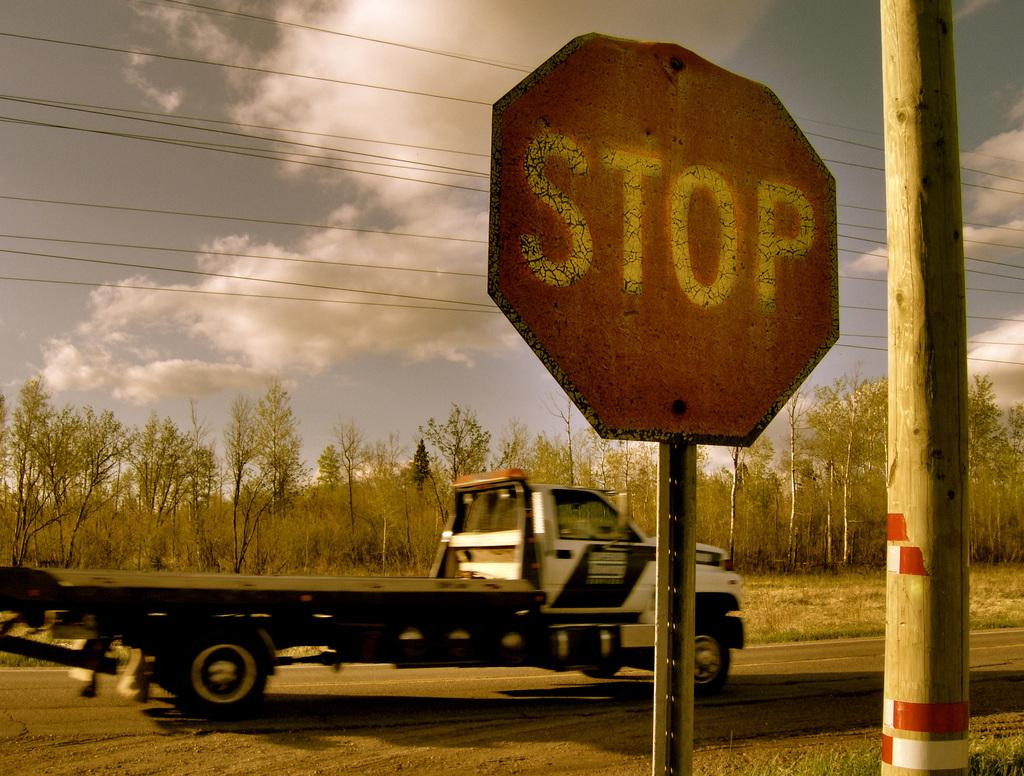Provide a one-sentence caption for the provided image. A tow truck with a flat bed is driving down a country road past an old stop sign next to a telephone pole. 